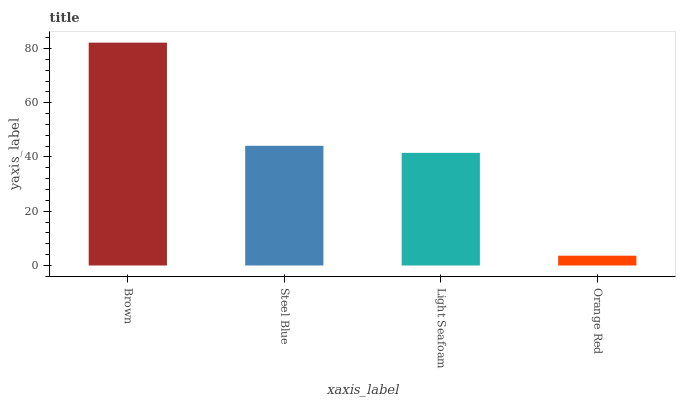Is Steel Blue the minimum?
Answer yes or no. No. Is Steel Blue the maximum?
Answer yes or no. No. Is Brown greater than Steel Blue?
Answer yes or no. Yes. Is Steel Blue less than Brown?
Answer yes or no. Yes. Is Steel Blue greater than Brown?
Answer yes or no. No. Is Brown less than Steel Blue?
Answer yes or no. No. Is Steel Blue the high median?
Answer yes or no. Yes. Is Light Seafoam the low median?
Answer yes or no. Yes. Is Brown the high median?
Answer yes or no. No. Is Orange Red the low median?
Answer yes or no. No. 